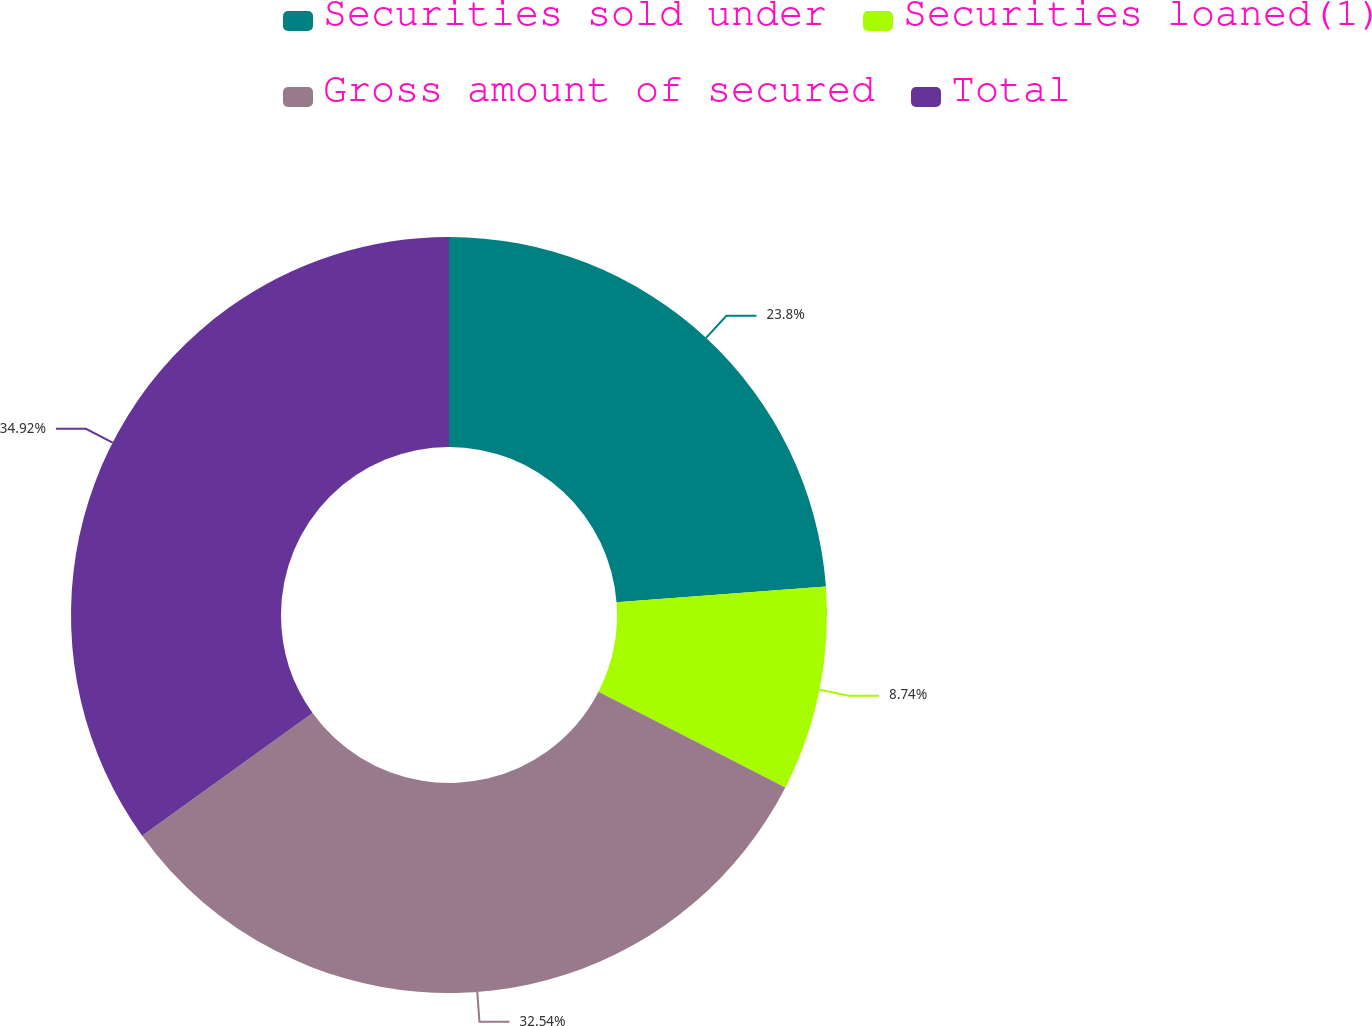Convert chart. <chart><loc_0><loc_0><loc_500><loc_500><pie_chart><fcel>Securities sold under<fcel>Securities loaned(1)<fcel>Gross amount of secured<fcel>Total<nl><fcel>23.8%<fcel>8.74%<fcel>32.54%<fcel>34.92%<nl></chart> 